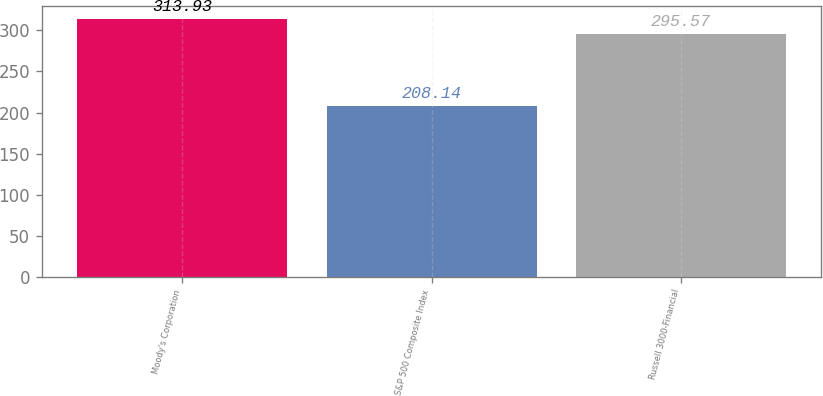Convert chart. <chart><loc_0><loc_0><loc_500><loc_500><bar_chart><fcel>Moody's Corporation<fcel>S&P 500 Composite Index<fcel>Russell 3000-Financial<nl><fcel>313.93<fcel>208.14<fcel>295.57<nl></chart> 